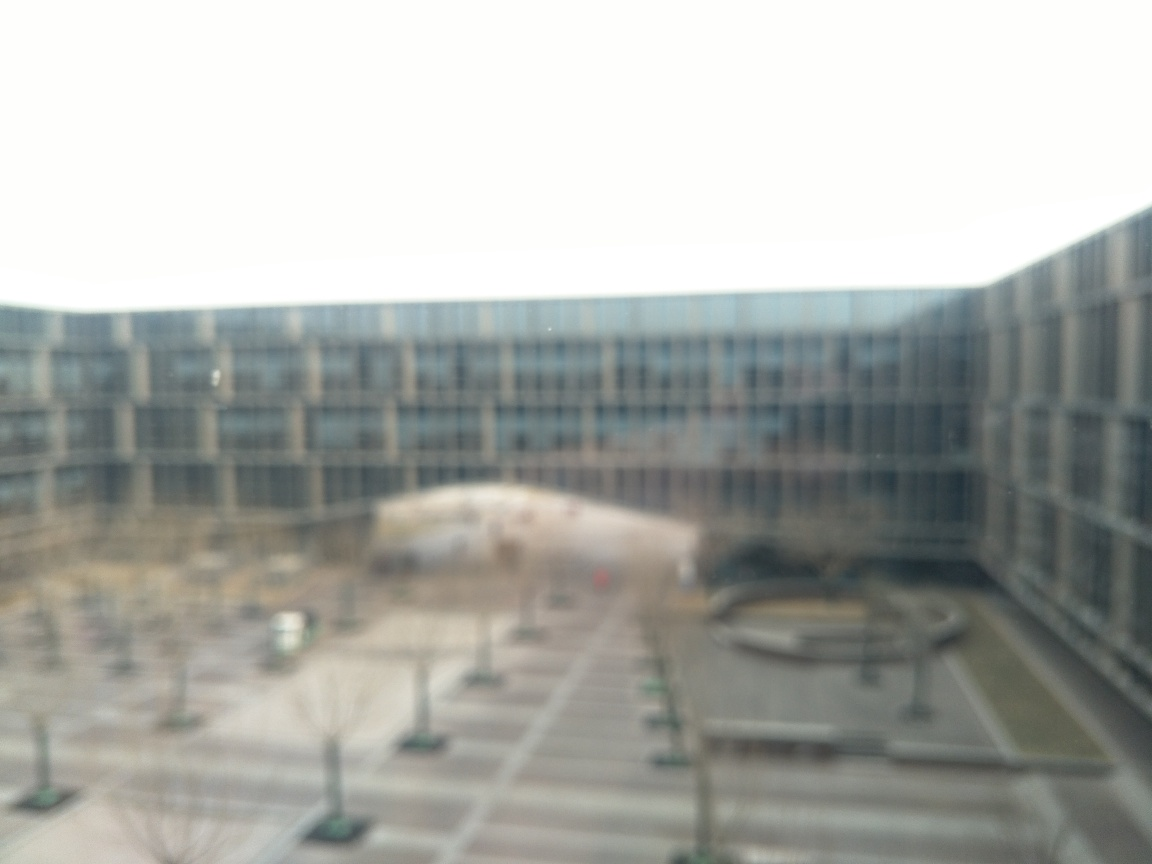Is the sharpness of the image noticeably low? Yes, the sharpness of the image is significantly low, resulting in a blurred view where details are not clearly discernible. The image lacks clear edges and fine details, causing a smeared or hazy appearance which suggests it may be out of focus or taken with a camera that moved during exposure. 